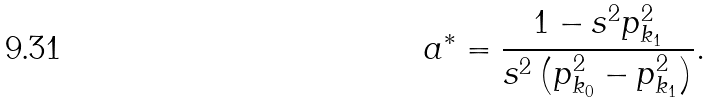<formula> <loc_0><loc_0><loc_500><loc_500>a ^ { * } = \frac { 1 - s ^ { 2 } p _ { k _ { 1 } } ^ { 2 } } { s ^ { 2 } \left ( p _ { k _ { 0 } } ^ { 2 } - p _ { k _ { 1 } } ^ { 2 } \right ) } .</formula> 